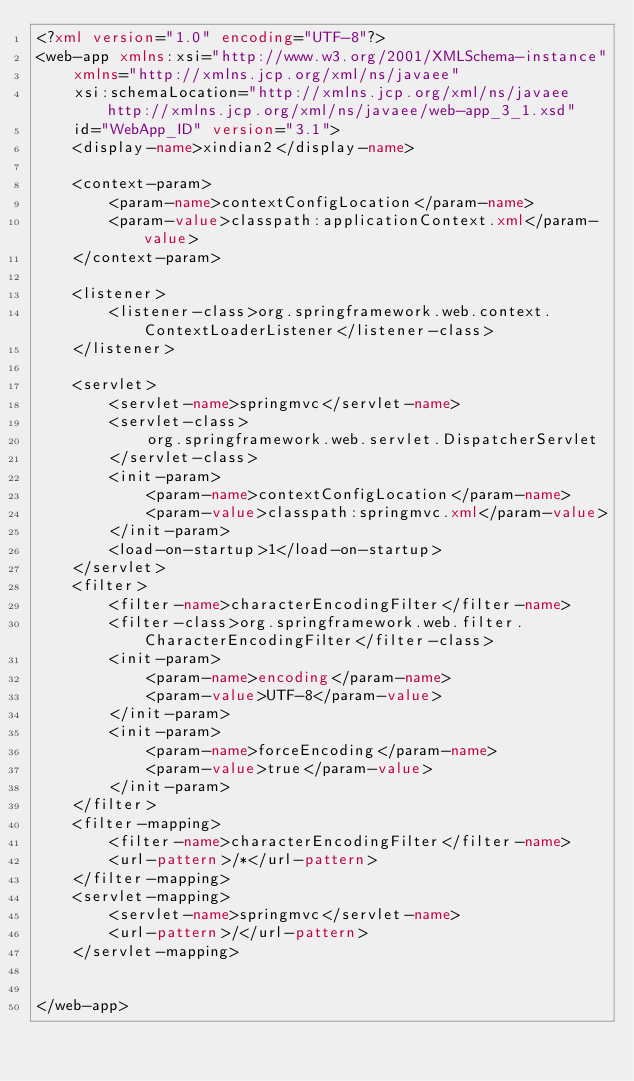<code> <loc_0><loc_0><loc_500><loc_500><_XML_><?xml version="1.0" encoding="UTF-8"?>
<web-app xmlns:xsi="http://www.w3.org/2001/XMLSchema-instance"
    xmlns="http://xmlns.jcp.org/xml/ns/javaee"
    xsi:schemaLocation="http://xmlns.jcp.org/xml/ns/javaee http://xmlns.jcp.org/xml/ns/javaee/web-app_3_1.xsd"
    id="WebApp_ID" version="3.1">
    <display-name>xindian2</display-name>

    <context-param>
        <param-name>contextConfigLocation</param-name>
        <param-value>classpath:applicationContext.xml</param-value>
    </context-param>

    <listener>
        <listener-class>org.springframework.web.context.ContextLoaderListener</listener-class>
    </listener>

    <servlet>
        <servlet-name>springmvc</servlet-name>
        <servlet-class>
            org.springframework.web.servlet.DispatcherServlet
        </servlet-class>
        <init-param>
            <param-name>contextConfigLocation</param-name>
            <param-value>classpath:springmvc.xml</param-value>
        </init-param>
        <load-on-startup>1</load-on-startup>
    </servlet>
    <filter>
        <filter-name>characterEncodingFilter</filter-name>
        <filter-class>org.springframework.web.filter.CharacterEncodingFilter</filter-class>
        <init-param>
            <param-name>encoding</param-name>
            <param-value>UTF-8</param-value>
        </init-param>
        <init-param>
            <param-name>forceEncoding</param-name>
            <param-value>true</param-value>
        </init-param>
    </filter>
    <filter-mapping>
        <filter-name>characterEncodingFilter</filter-name>
        <url-pattern>/*</url-pattern>
    </filter-mapping>
    <servlet-mapping>
        <servlet-name>springmvc</servlet-name>
        <url-pattern>/</url-pattern>
    </servlet-mapping>


</web-app></code> 